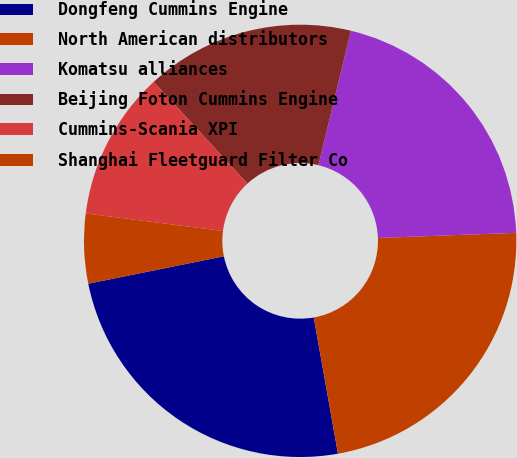Convert chart. <chart><loc_0><loc_0><loc_500><loc_500><pie_chart><fcel>Dongfeng Cummins Engine<fcel>North American distributors<fcel>Komatsu alliances<fcel>Beijing Foton Cummins Engine<fcel>Cummins-Scania XPI<fcel>Shanghai Fleetguard Filter Co<nl><fcel>24.62%<fcel>22.79%<fcel>20.64%<fcel>15.61%<fcel>11.13%<fcel>5.2%<nl></chart> 